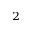Convert formula to latex. <formula><loc_0><loc_0><loc_500><loc_500>^ { 2 }</formula> 